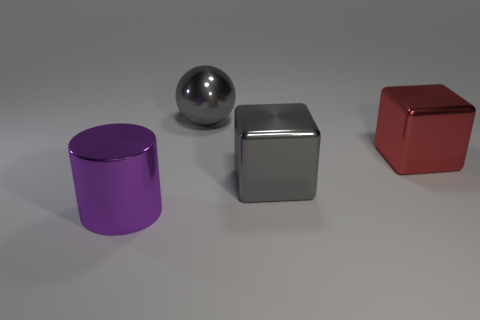Are there any other things that are the same shape as the purple metal object?
Your answer should be compact. No. Are there fewer large red metallic things than large objects?
Keep it short and to the point. Yes. Is there a large purple metal object that is to the right of the large gray metallic thing that is behind the big gray shiny cube?
Your response must be concise. No. What number of things are either gray things or big cubes?
Make the answer very short. 3. What shape is the large metal object that is both on the right side of the large shiny sphere and to the left of the red shiny cube?
Ensure brevity in your answer.  Cube. Is the material of the thing behind the red shiny cube the same as the big purple object?
Provide a short and direct response. Yes. What number of objects are purple objects or metallic things that are behind the large cylinder?
Offer a terse response. 4. There is a large ball that is the same material as the large cylinder; what color is it?
Offer a very short reply. Gray. What number of spheres are the same material as the big cylinder?
Ensure brevity in your answer.  1. What number of gray metal spheres are there?
Your response must be concise. 1. 